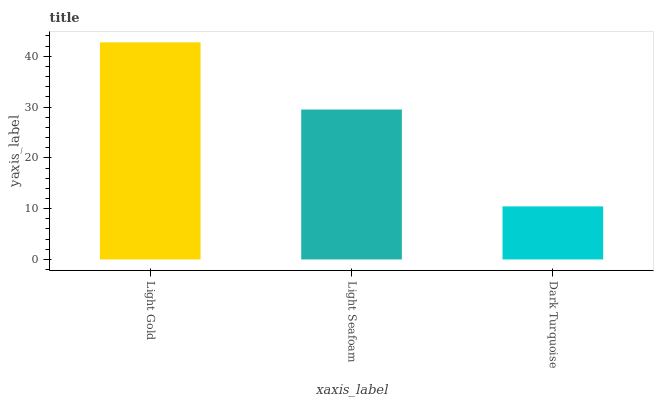Is Dark Turquoise the minimum?
Answer yes or no. Yes. Is Light Gold the maximum?
Answer yes or no. Yes. Is Light Seafoam the minimum?
Answer yes or no. No. Is Light Seafoam the maximum?
Answer yes or no. No. Is Light Gold greater than Light Seafoam?
Answer yes or no. Yes. Is Light Seafoam less than Light Gold?
Answer yes or no. Yes. Is Light Seafoam greater than Light Gold?
Answer yes or no. No. Is Light Gold less than Light Seafoam?
Answer yes or no. No. Is Light Seafoam the high median?
Answer yes or no. Yes. Is Light Seafoam the low median?
Answer yes or no. Yes. Is Light Gold the high median?
Answer yes or no. No. Is Light Gold the low median?
Answer yes or no. No. 